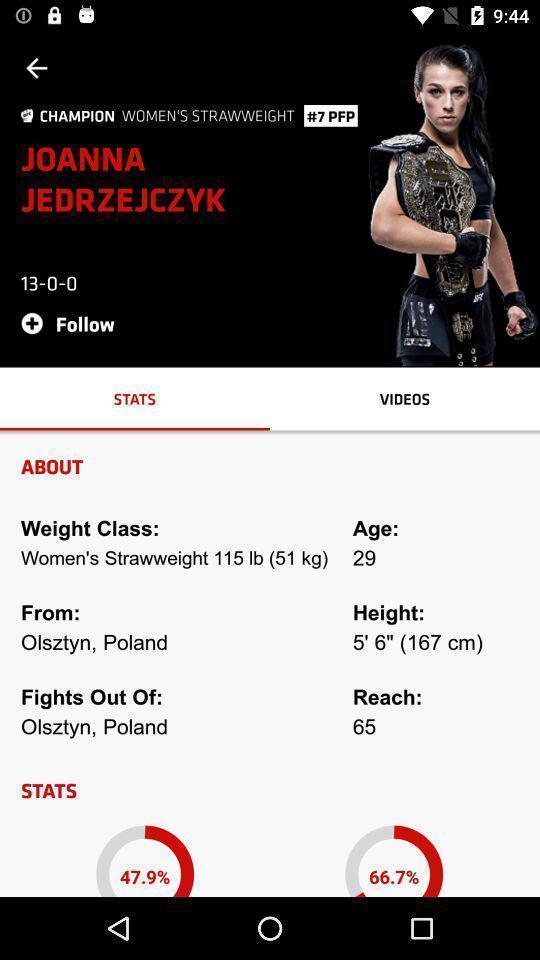Summarize the main components in this picture. Page displaying stats of weight lifter of an sports app. 